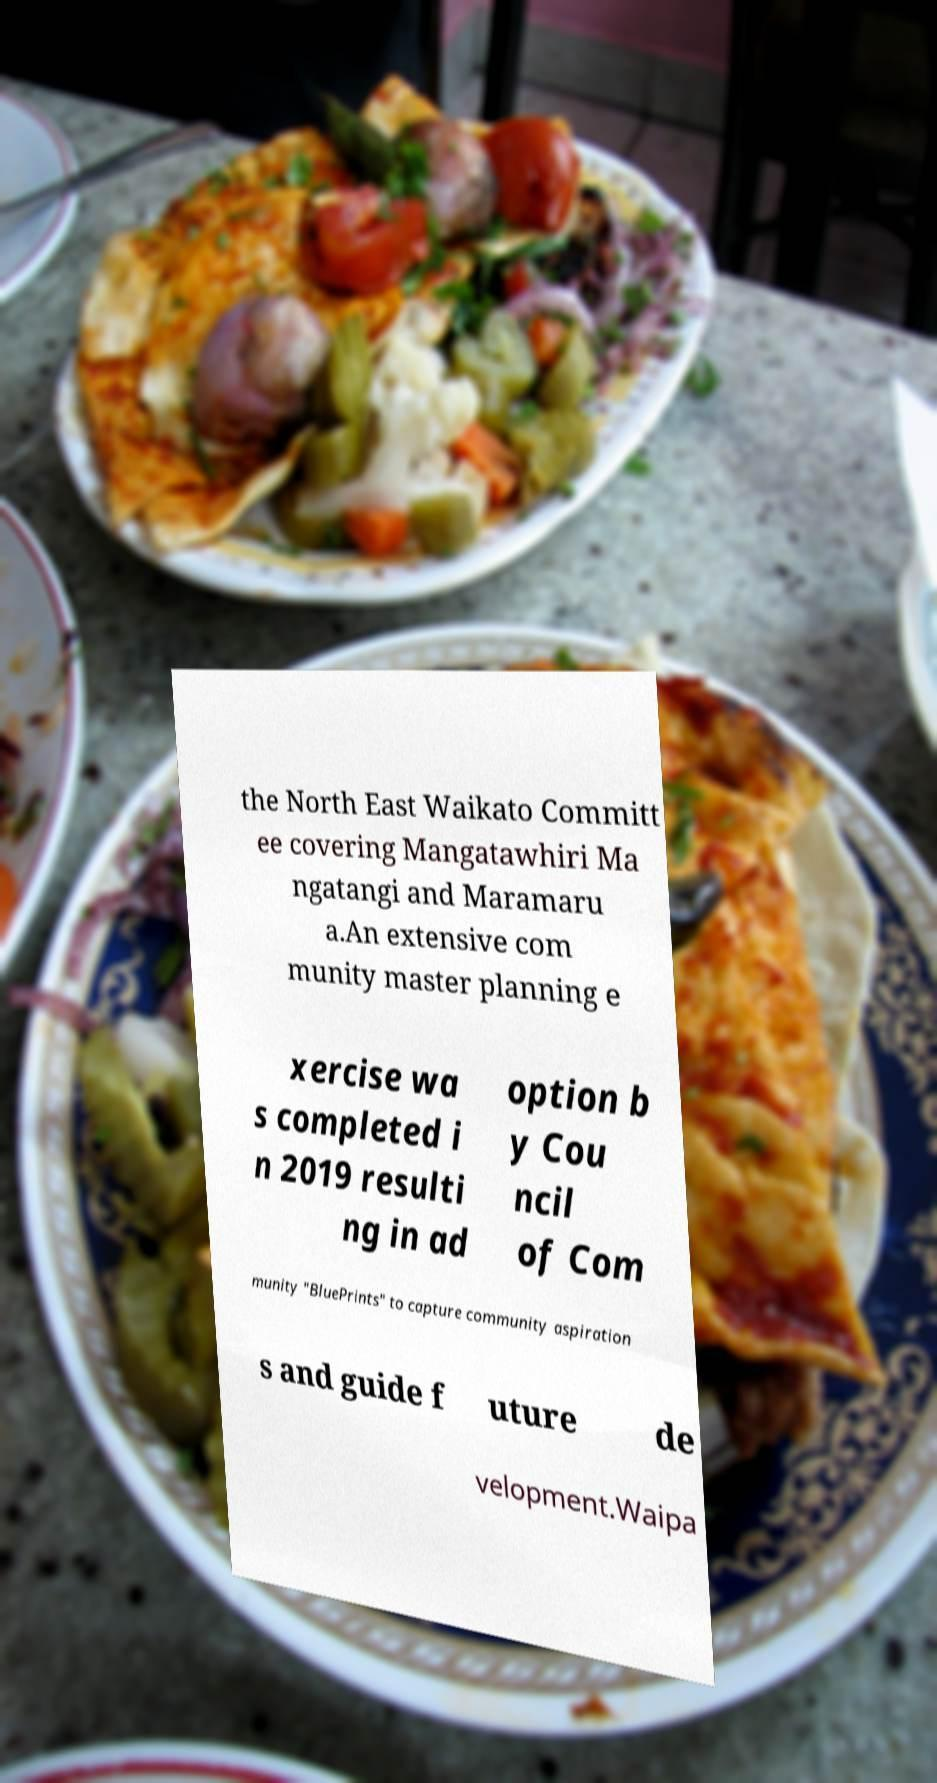Could you assist in decoding the text presented in this image and type it out clearly? the North East Waikato Committ ee covering Mangatawhiri Ma ngatangi and Maramaru a.An extensive com munity master planning e xercise wa s completed i n 2019 resulti ng in ad option b y Cou ncil of Com munity "BluePrints" to capture community aspiration s and guide f uture de velopment.Waipa 